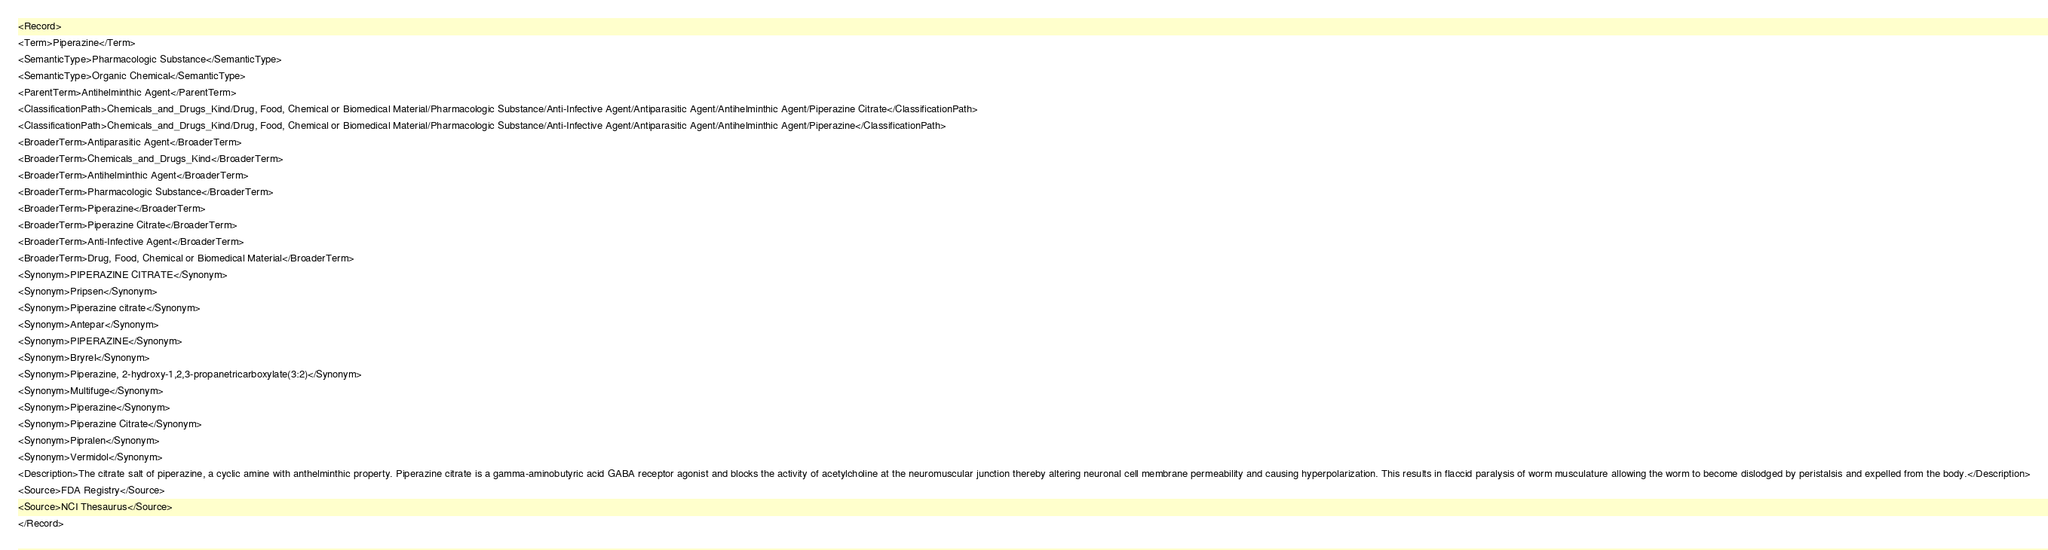Convert code to text. <code><loc_0><loc_0><loc_500><loc_500><_XML_><Record>
<Term>Piperazine</Term>
<SemanticType>Pharmacologic Substance</SemanticType>
<SemanticType>Organic Chemical</SemanticType>
<ParentTerm>Antihelminthic Agent</ParentTerm>
<ClassificationPath>Chemicals_and_Drugs_Kind/Drug, Food, Chemical or Biomedical Material/Pharmacologic Substance/Anti-Infective Agent/Antiparasitic Agent/Antihelminthic Agent/Piperazine Citrate</ClassificationPath>
<ClassificationPath>Chemicals_and_Drugs_Kind/Drug, Food, Chemical or Biomedical Material/Pharmacologic Substance/Anti-Infective Agent/Antiparasitic Agent/Antihelminthic Agent/Piperazine</ClassificationPath>
<BroaderTerm>Antiparasitic Agent</BroaderTerm>
<BroaderTerm>Chemicals_and_Drugs_Kind</BroaderTerm>
<BroaderTerm>Antihelminthic Agent</BroaderTerm>
<BroaderTerm>Pharmacologic Substance</BroaderTerm>
<BroaderTerm>Piperazine</BroaderTerm>
<BroaderTerm>Piperazine Citrate</BroaderTerm>
<BroaderTerm>Anti-Infective Agent</BroaderTerm>
<BroaderTerm>Drug, Food, Chemical or Biomedical Material</BroaderTerm>
<Synonym>PIPERAZINE CITRATE</Synonym>
<Synonym>Pripsen</Synonym>
<Synonym>Piperazine citrate</Synonym>
<Synonym>Antepar</Synonym>
<Synonym>PIPERAZINE</Synonym>
<Synonym>Bryrel</Synonym>
<Synonym>Piperazine, 2-hydroxy-1,2,3-propanetricarboxylate(3:2)</Synonym>
<Synonym>Multifuge</Synonym>
<Synonym>Piperazine</Synonym>
<Synonym>Piperazine Citrate</Synonym>
<Synonym>Pipralen</Synonym>
<Synonym>Vermidol</Synonym>
<Description>The citrate salt of piperazine, a cyclic amine with anthelminthic property. Piperazine citrate is a gamma-aminobutyric acid GABA receptor agonist and blocks the activity of acetylcholine at the neuromuscular junction thereby altering neuronal cell membrane permeability and causing hyperpolarization. This results in flaccid paralysis of worm musculature allowing the worm to become dislodged by peristalsis and expelled from the body.</Description>
<Source>FDA Registry</Source>
<Source>NCI Thesaurus</Source>
</Record>
</code> 